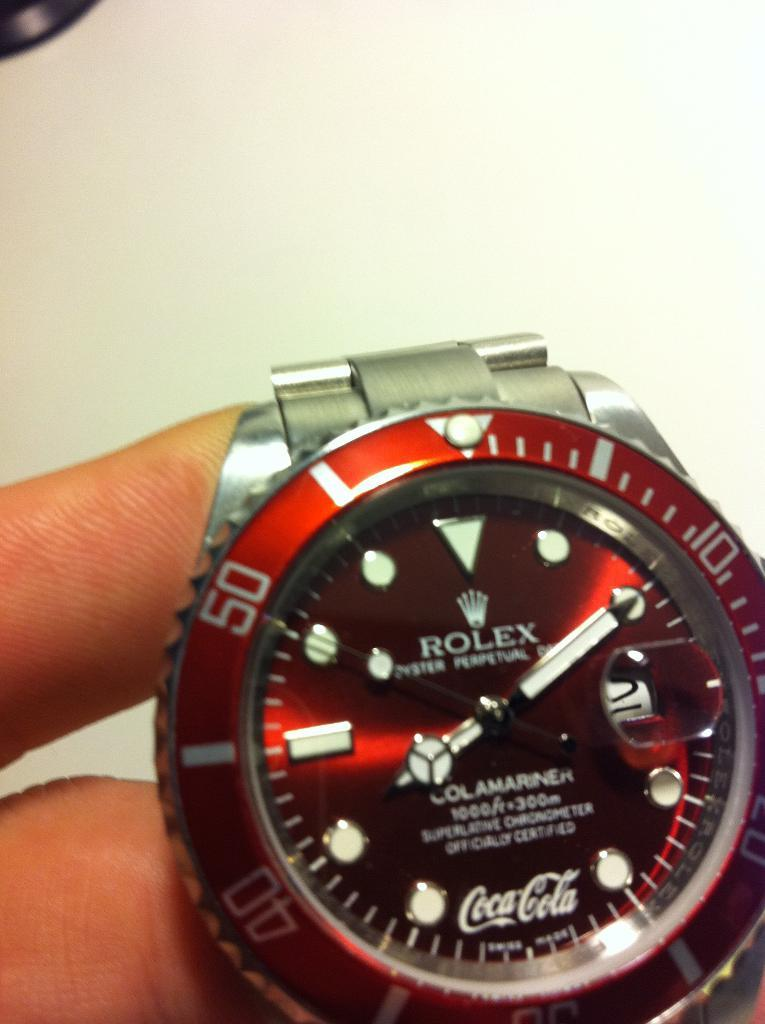<image>
Summarize the visual content of the image. A Rolex watch has the Coca-cola logo on it. 